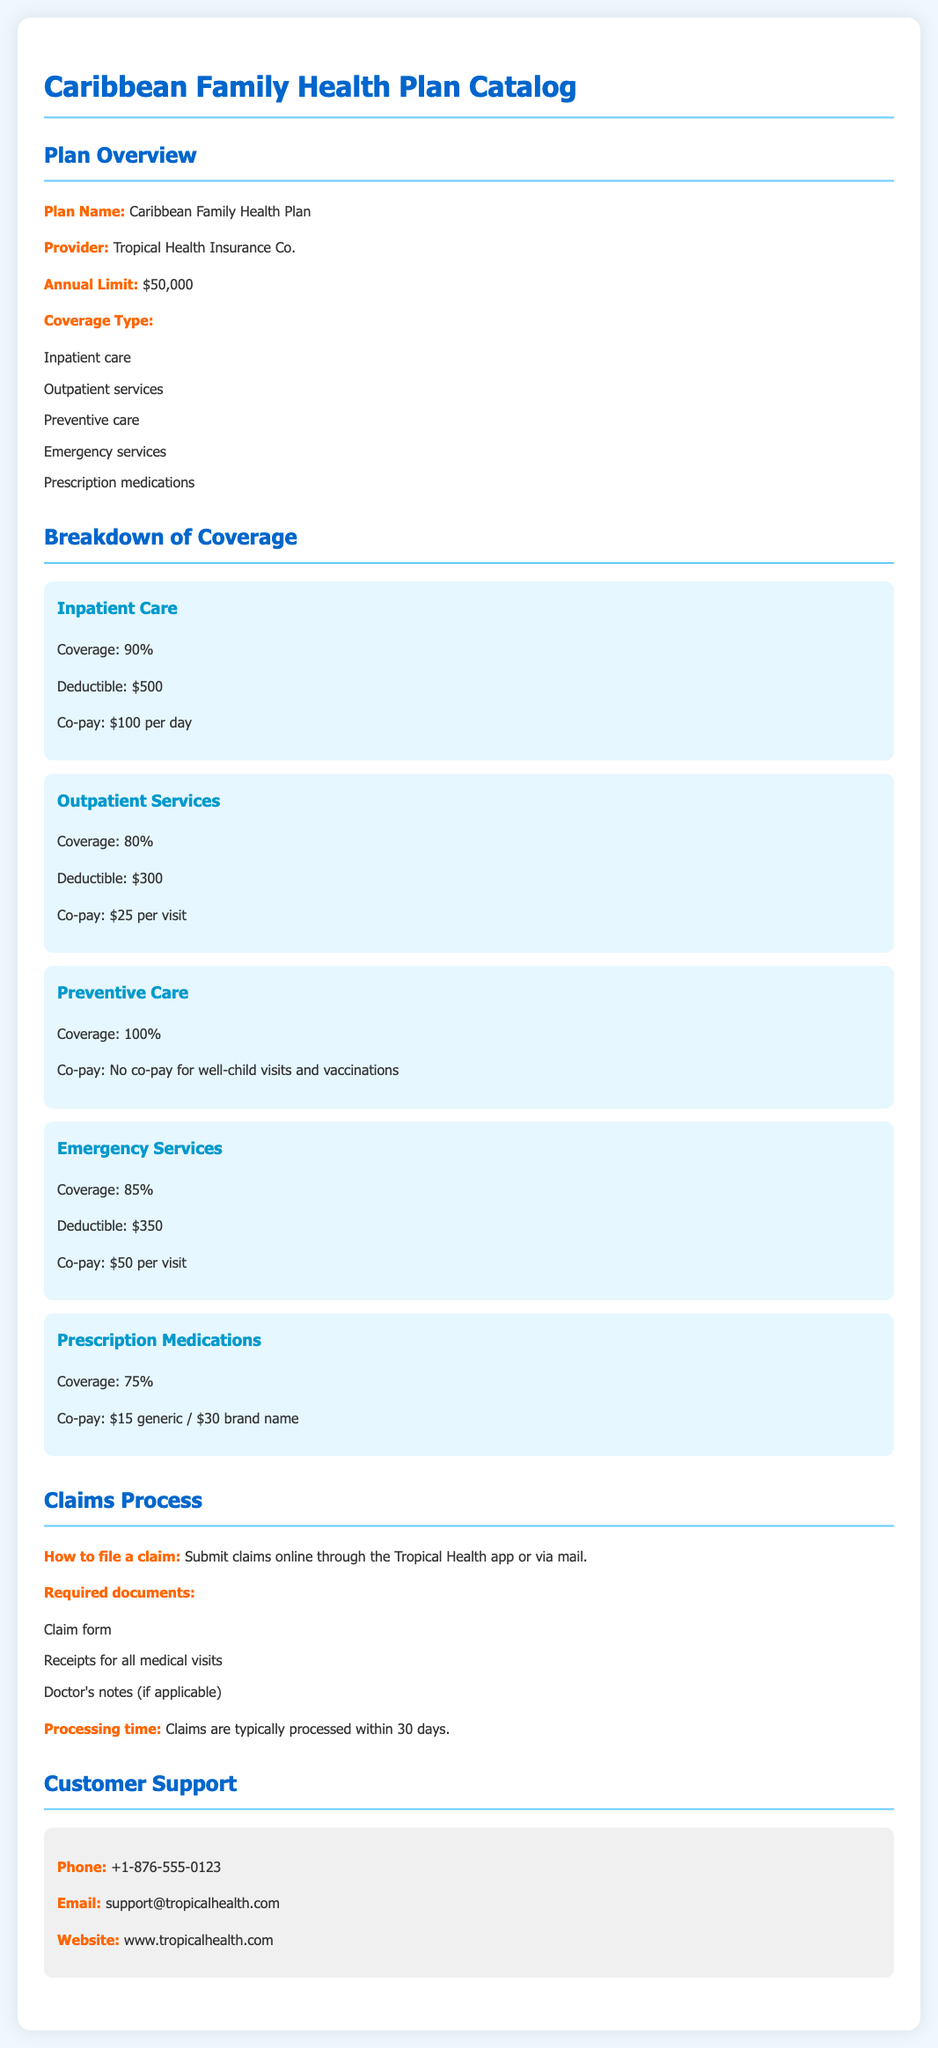What is the plan name? The plan name is listed in the document section, which states "Caribbean Family Health Plan."
Answer: Caribbean Family Health Plan What is the annual limit for the plan? The annual limit is provided in the overview section of the document, which states "$50,000."
Answer: $50,000 What percentage coverage does preventive care offer? The document specifies that preventive care has "100%" coverage.
Answer: 100% What is the co-pay for outpatient services? The breakdown of outpatient services shows a "Co-pay: $25 per visit."
Answer: $25 per visit What is the required deductible for inpatient care? The deductible for inpatient care is listed as "$500."
Answer: $500 How long does it typically take to process claims? The document states the processing time as "30 days."
Answer: 30 days What documents are needed to file a claim? The document lists specific documents such as the claim form and receipts.
Answer: Claim form, Receipts for all medical visits, Doctor's notes (if applicable) What is the coverage percentage for prescription medications? The coverage for prescription medications is mentioned as "75%."
Answer: 75% How can claims be submitted? The document states that claims can be submitted "online through the Tropical Health app or via mail."
Answer: Online or via mail 